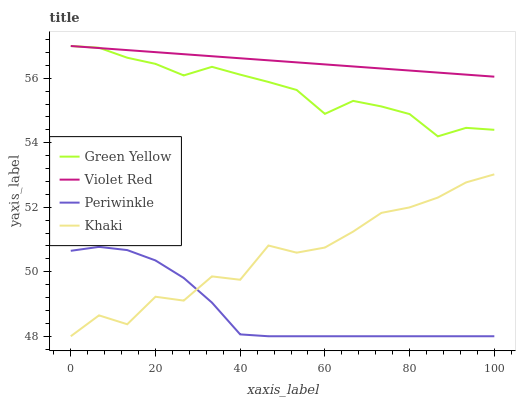Does Periwinkle have the minimum area under the curve?
Answer yes or no. Yes. Does Violet Red have the maximum area under the curve?
Answer yes or no. Yes. Does Green Yellow have the minimum area under the curve?
Answer yes or no. No. Does Green Yellow have the maximum area under the curve?
Answer yes or no. No. Is Violet Red the smoothest?
Answer yes or no. Yes. Is Khaki the roughest?
Answer yes or no. Yes. Is Green Yellow the smoothest?
Answer yes or no. No. Is Green Yellow the roughest?
Answer yes or no. No. Does Periwinkle have the lowest value?
Answer yes or no. Yes. Does Green Yellow have the lowest value?
Answer yes or no. No. Does Green Yellow have the highest value?
Answer yes or no. Yes. Does Periwinkle have the highest value?
Answer yes or no. No. Is Periwinkle less than Green Yellow?
Answer yes or no. Yes. Is Green Yellow greater than Periwinkle?
Answer yes or no. Yes. Does Violet Red intersect Green Yellow?
Answer yes or no. Yes. Is Violet Red less than Green Yellow?
Answer yes or no. No. Is Violet Red greater than Green Yellow?
Answer yes or no. No. Does Periwinkle intersect Green Yellow?
Answer yes or no. No. 